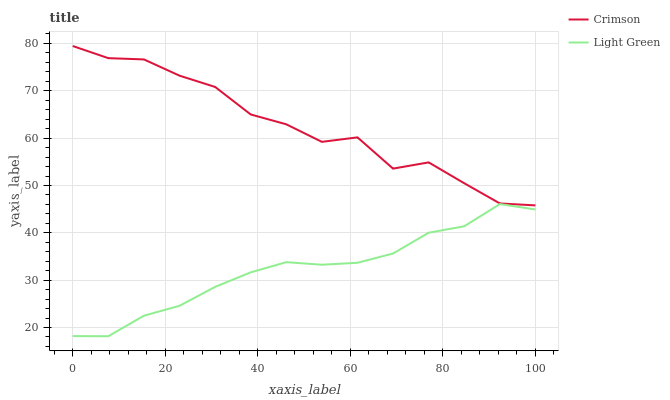Does Light Green have the minimum area under the curve?
Answer yes or no. Yes. Does Crimson have the maximum area under the curve?
Answer yes or no. Yes. Does Light Green have the maximum area under the curve?
Answer yes or no. No. Is Light Green the smoothest?
Answer yes or no. Yes. Is Crimson the roughest?
Answer yes or no. Yes. Is Light Green the roughest?
Answer yes or no. No. Does Light Green have the lowest value?
Answer yes or no. Yes. Does Crimson have the highest value?
Answer yes or no. Yes. Does Light Green have the highest value?
Answer yes or no. No. Is Light Green less than Crimson?
Answer yes or no. Yes. Is Crimson greater than Light Green?
Answer yes or no. Yes. Does Light Green intersect Crimson?
Answer yes or no. No. 